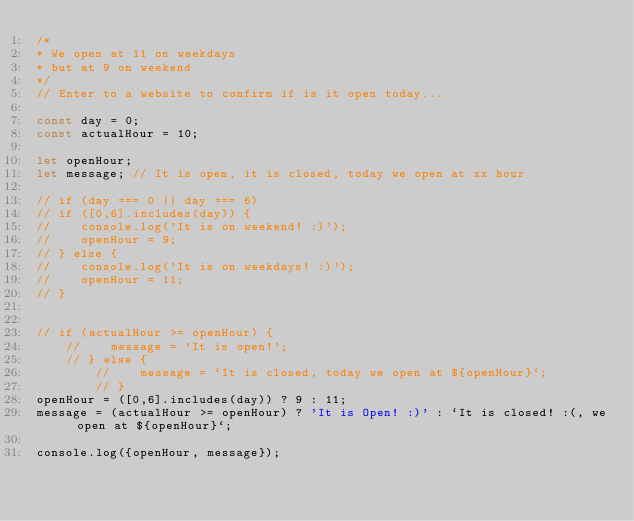<code> <loc_0><loc_0><loc_500><loc_500><_JavaScript_>/*
* We open at 11 on weekdays
* but at 9 on weekend
*/
// Enter to a website to confirm if is it open today...

const day = 0;
const actualHour = 10;

let openHour;
let message; // It is open, it is closed, today we open at xx hour

// if (day === 0 || day === 6)
// if ([0,6].includes(day)) {
//    console.log('It is on weekend! :)');
//    openHour = 9;
// } else {
//    console.log('It is on weekdays! :)');
//    openHour = 11;
// }


// if (actualHour >= openHour) {
    //    message = 'It is open!';
    // } else {
        //    message = `It is closed, today we open at ${openHour}`;
        // }
openHour = ([0,6].includes(day)) ? 9 : 11;
message = (actualHour >= openHour) ? 'It is Open! :)' : `It is closed! :(, we open at ${openHour}`;

console.log({openHour, message});</code> 